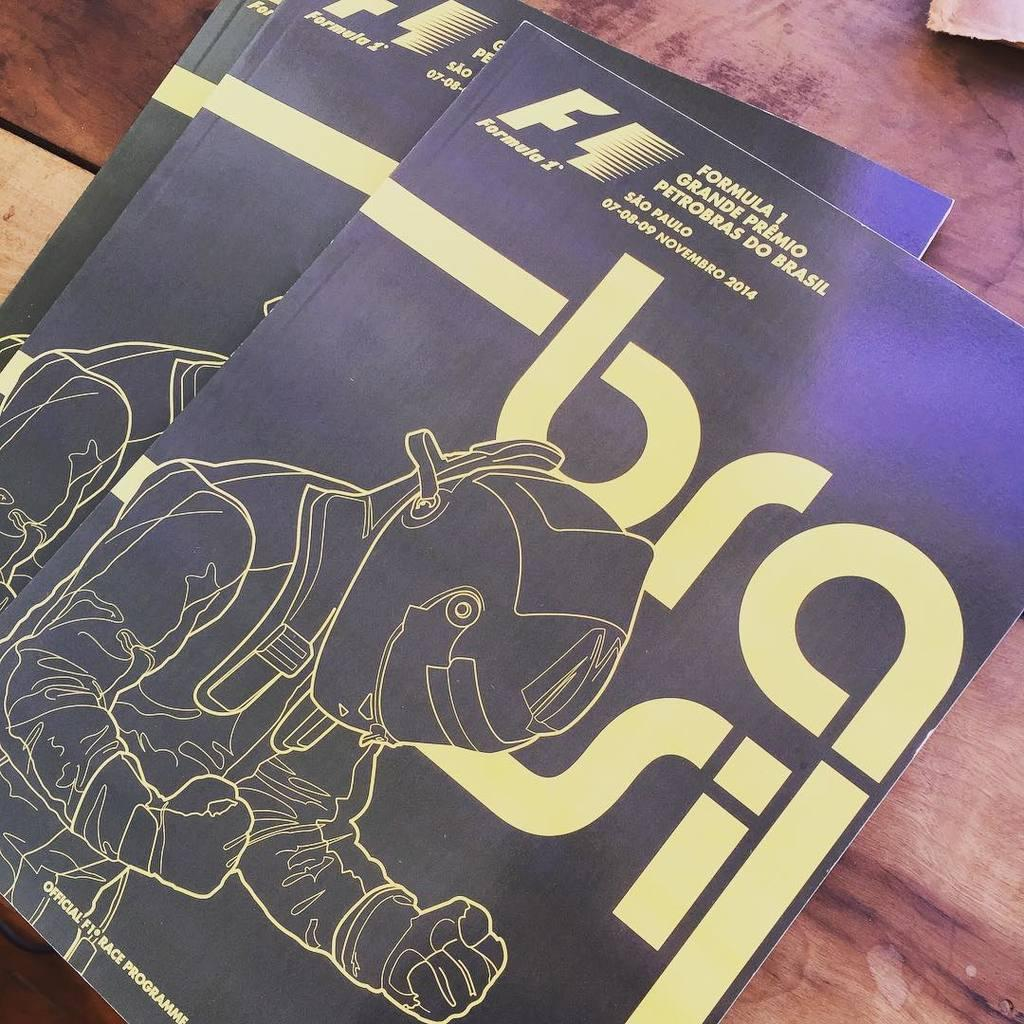<image>
Describe the image concisely. a book on top of another book that says 'formula' on the top of it 